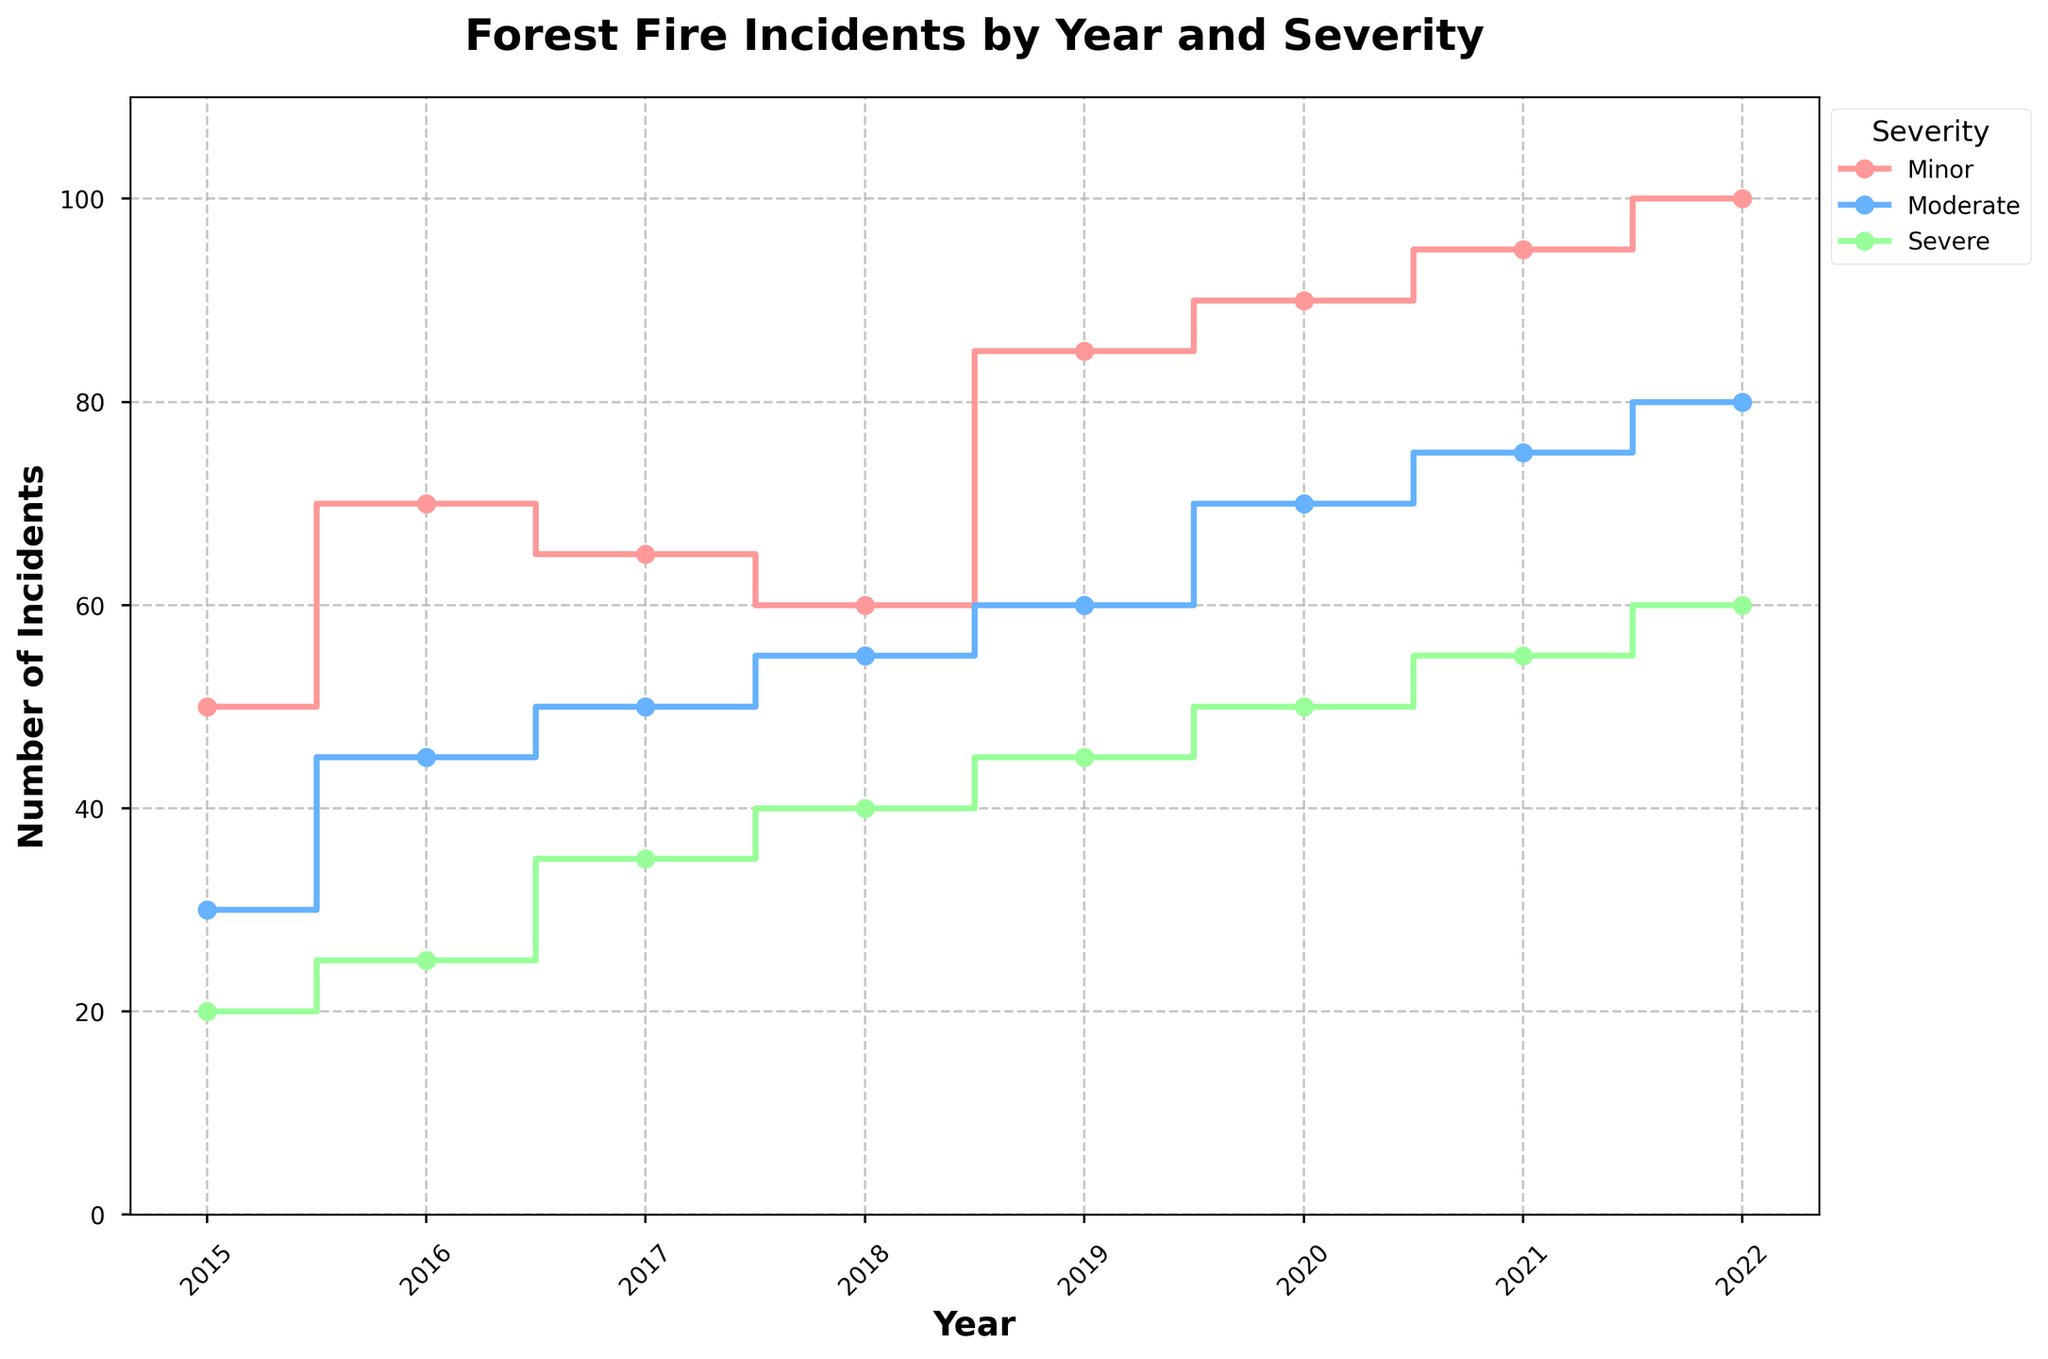What is the title of the figure? The title is usually found at the top of the plot. In this case, it reads "Forest Fire Incidents by Year and Severity."
Answer: Forest Fire Incidents by Year and Severity What are the labels of the x-axis and y-axis? The x-axis label is at the bottom of the plot, and the y-axis label is along the side. In this figure, the x-axis is labeled "Year," and the y-axis is labeled "Number of Incidents."
Answer: Year (x-axis) and Number of Incidents (y-axis) Which year had the highest number of severe incidents? Look for the highest point in the 'Severe' series. According to the plot, the highest severe incidents occur in 2022.
Answer: 2022 How do moderate incidents in 2018 compare to those in 2016? Compare the height of the 'Moderate' step line in 2018 to that in 2016. In 2018, the moderate incidents are 55, whereas in 2016, they are 45.
Answer: 2018 has 10 more incidents than 2016 What is the difference in the total number of incidents between 2021 and 2015? Sum the total incidents for each severity in both years and then subtract 2015 from 2021. For 2021: 95 (Minor) + 75 (Moderate) + 55 (Severe) = 225. For 2015: 50 (Minor) + 30 (Moderate) + 20 (Severe) = 100. Then, 225 - 100 = 125.
Answer: 125 Which severity had the steepest overall increase from 2015 to 2022? Look at the increase in each severity from 2015 to 2022. Increase for Minor: 100 - 50 = 50, for Moderate: 80 - 30 = 50, for Severe: 60 - 20 = 40. Both Minor and Moderate saw the steepest increase of 50 incidents.
Answer: Minor and Moderate What is the trend of minor incidents from 2015 to 2022? Follow the 'Minor' step line from 2015 to 2022. It generally shows an increasing trend each year.
Answer: Increasing trend How many total incidents occurred in 2020? Add the incidents from all severities for 2020. 90 (Minor) + 70 (Moderate) + 50 (Severe) = 210.
Answer: 210 In which year did moderate incidents surpass 50 for the first time? Follow the 'Moderate' step line to see where it first exceeds 50. It surpasses 50 in 2018.
Answer: 2018 What is the average number of severe incidents per year from 2015 to 2022? Calculate the average by summing the severe incidents and dividing by the number of years. (20 + 25 + 35 + 40 + 45 + 50 + 55 + 60) / 8 = 41.25.
Answer: 41.25 